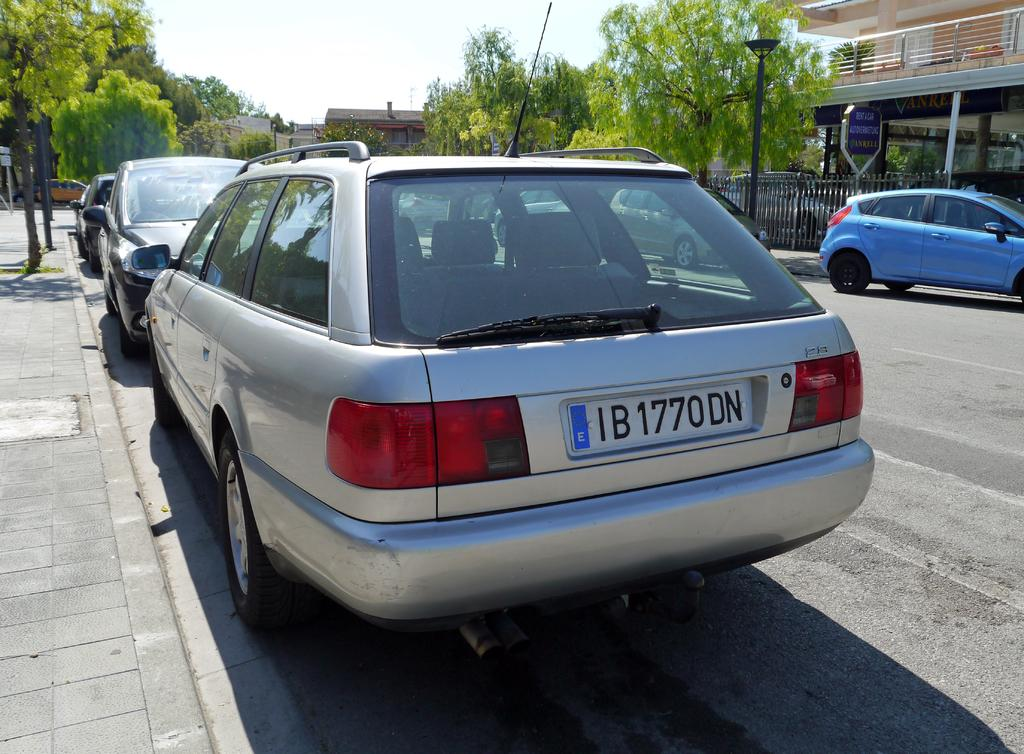<image>
Create a compact narrative representing the image presented. A parked silver car has a license plate that reads IB1770DN. 